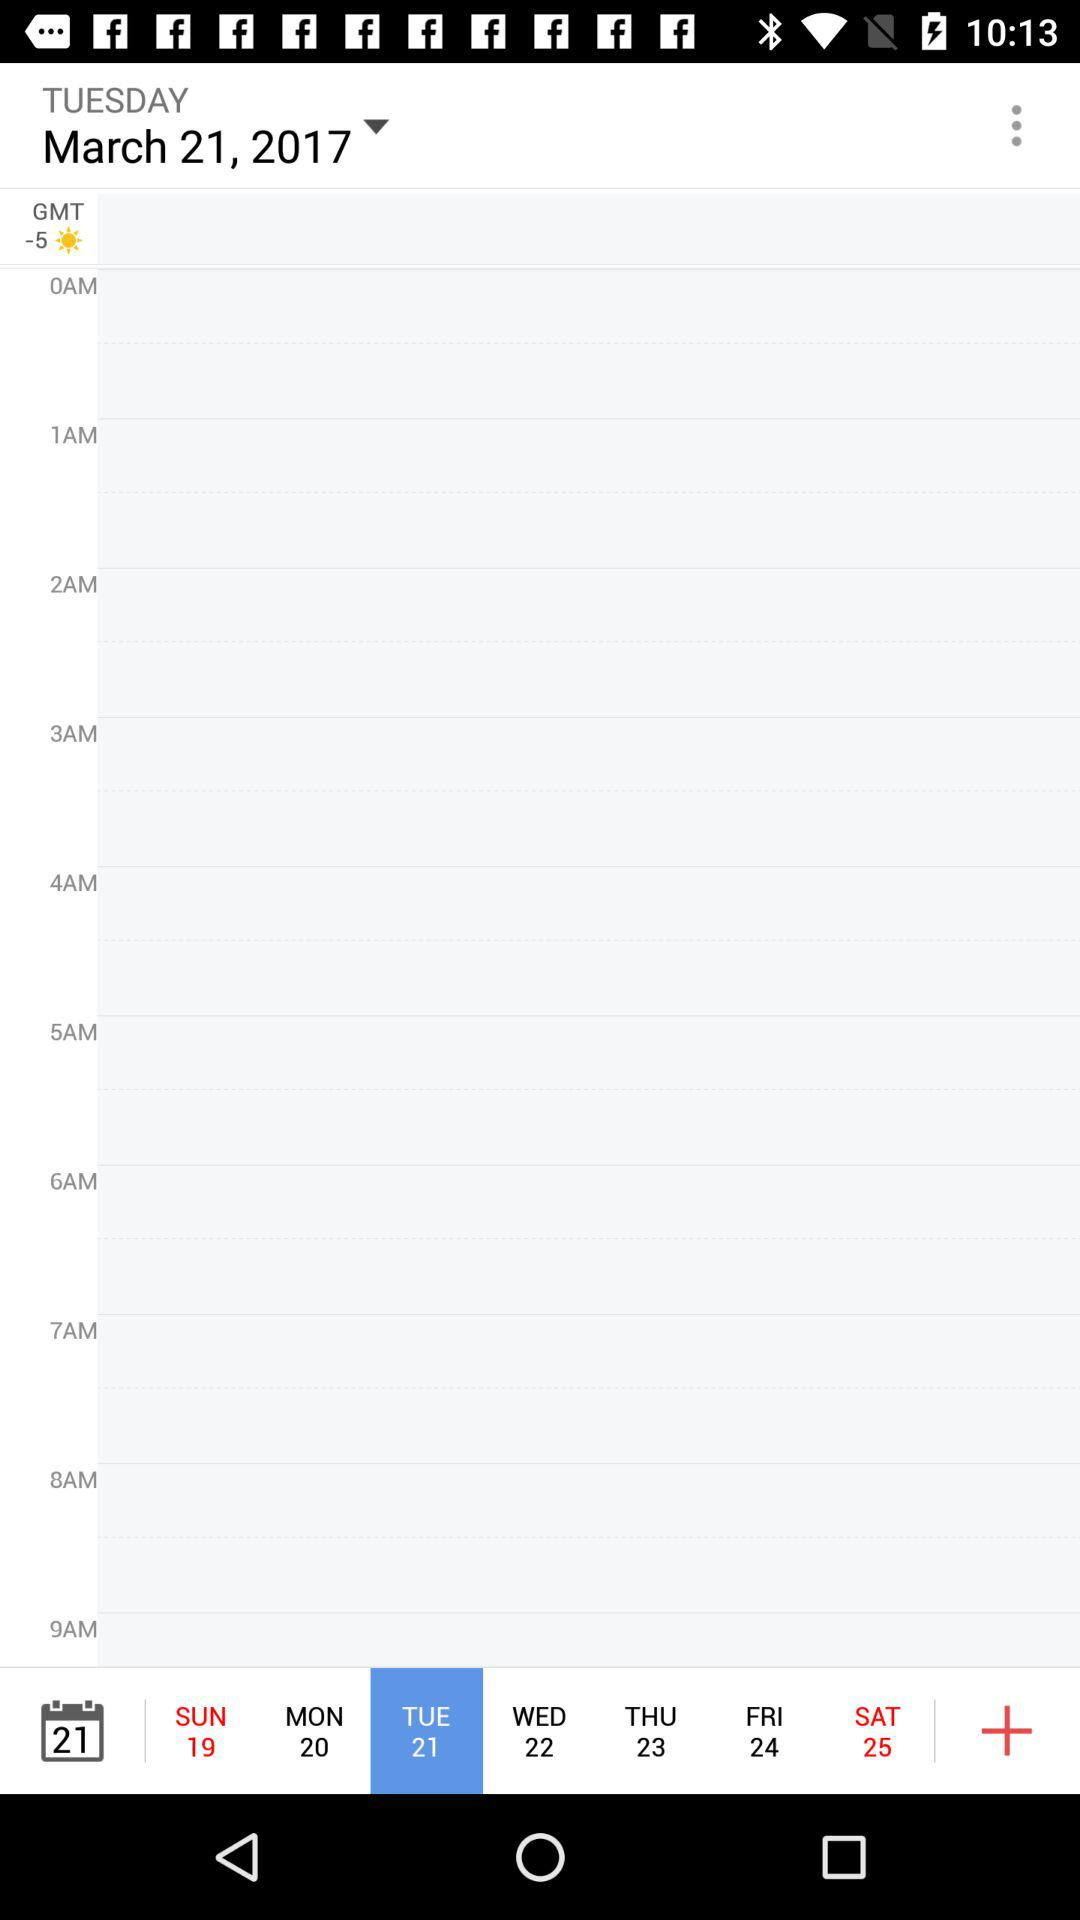Which date has been selected? The date that has been selected is Tuesday, March 21, 2017. 